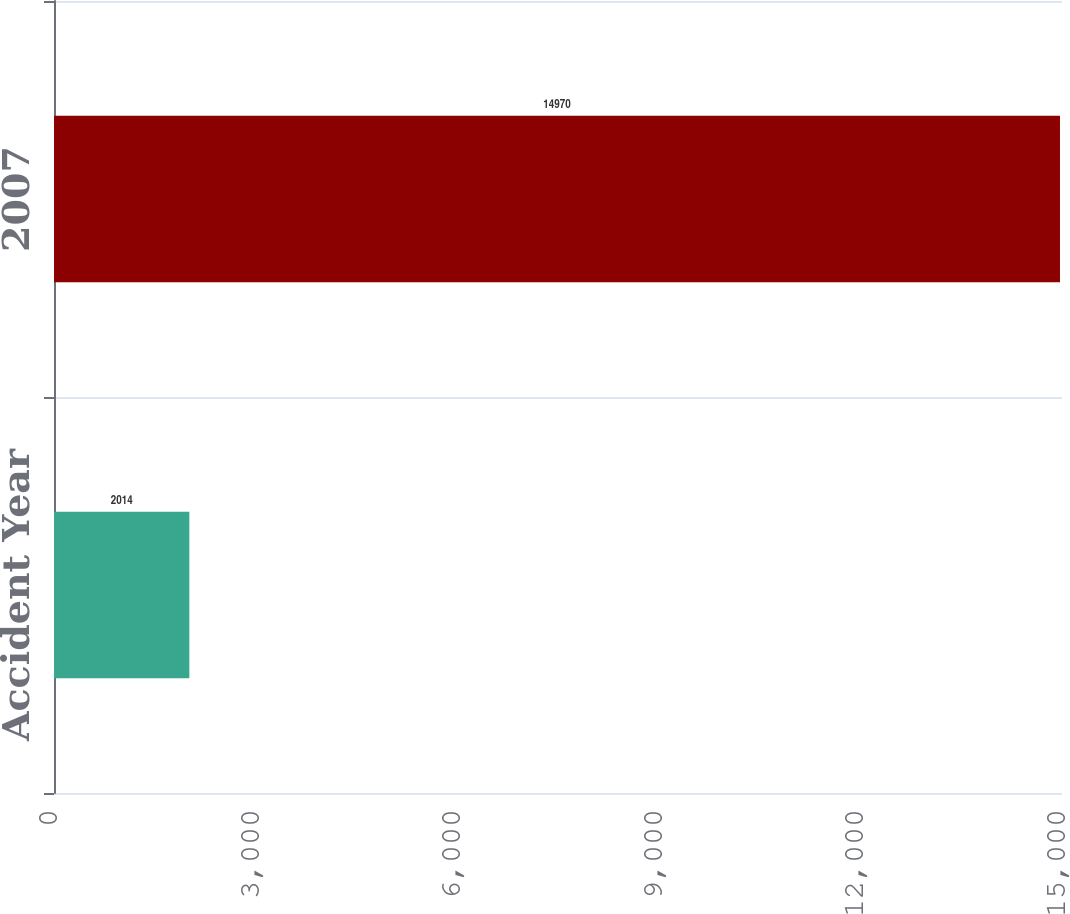<chart> <loc_0><loc_0><loc_500><loc_500><bar_chart><fcel>Accident Year<fcel>2007<nl><fcel>2014<fcel>14970<nl></chart> 